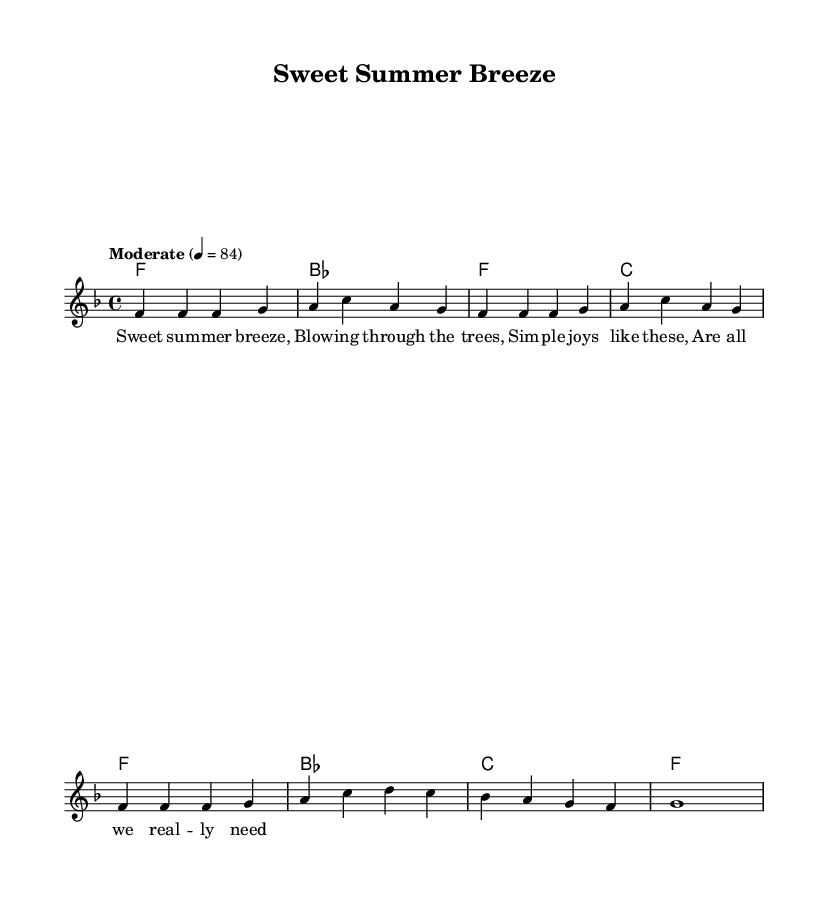What is the key signature of this music? The key signature is F major, which has one flat (B flat). This is identified by looking at the beginning of the staff where the key signature symbols are placed.
Answer: F major What is the time signature of this music? The time signature is 4/4, which is indicated right after the key signature on the staff, showing that there are four beats in a measure and the quarter note gets one beat.
Answer: 4/4 What is the tempo marking of this piece? The tempo marking is "Moderate" at a speed of 84 beats per minute. This is found at the beginning of the score, indicating how fast the music should be played.
Answer: Moderate, 84 How many measures are in the melody section? The melody section consists of 8 measures. This can be counted by observing the divisions created by vertical lines on the music staff.
Answer: 8 What is the primary theme of the lyrics? The primary theme of the lyrics is celebrating simple joys and the beauty of nature, as reflected in phrases like "Sweet summer breeze" and "Simple joys like these." This theme connects well with the nostalgic feel typical of R&B music from the 70s and 80s.
Answer: Celebrating simple joys What chord follows the "a c a g" notes in the melody? The chord that follows the "a c a g" notes is F major, which can be inferred from the chord progression shown in the harmonies section right below the melody line.
Answer: F major What is a prominent characteristic of Rhythm and Blues music reflected in this piece? A prominent characteristic reflected in this piece is the emphasis on soulful melodies and heartfelt lyrics that focus on emotional themes such as love and nostalgia, which are staples in R&B music. This is evident in both the melody and the lyrical content.
Answer: Soulful melodies and heartfelt lyrics 